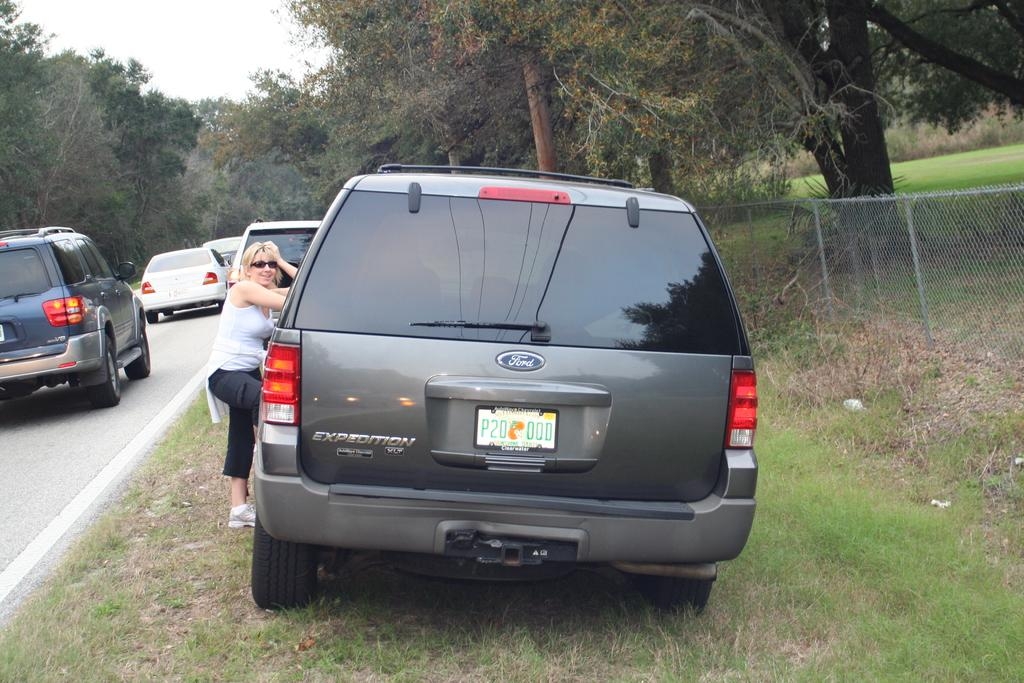<image>
Provide a brief description of the given image. The grey Ford pulled onto the rass alongside the road is from Clearwater 